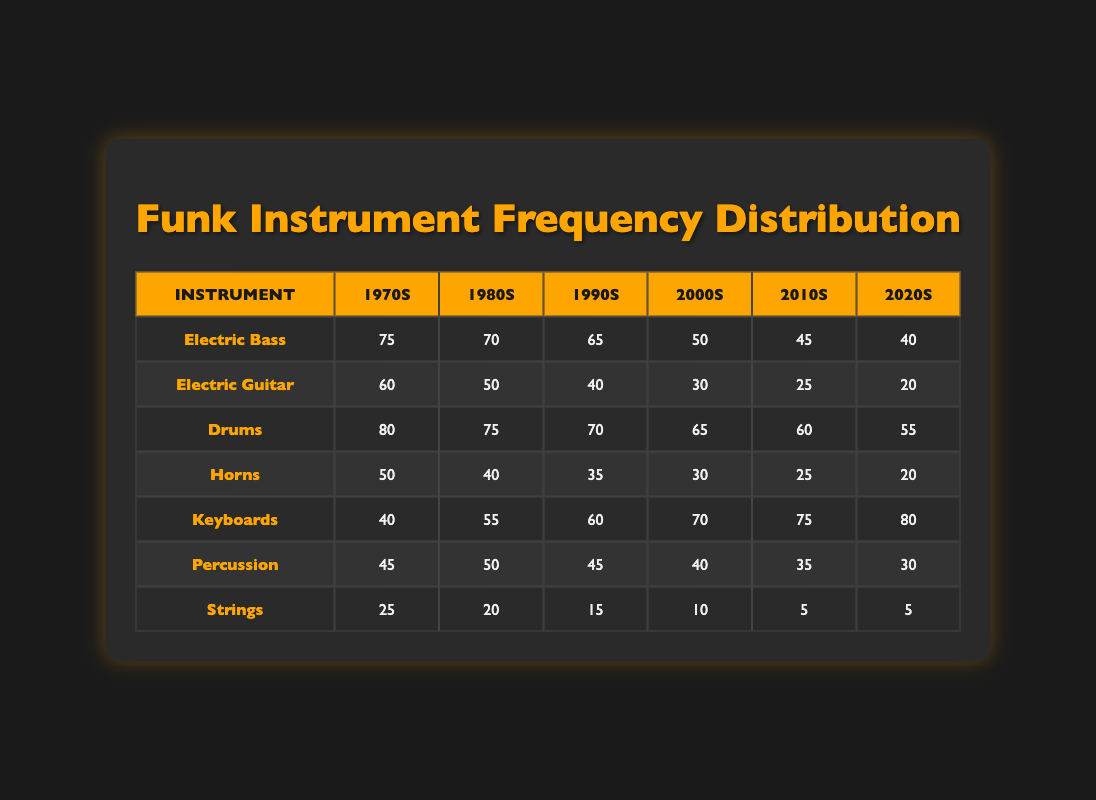What instrument had the highest frequency in the 1970s? From the table, I look at the "1970s" column and find the values for each instrument. The instrument with the highest frequency is "Drums" with a frequency of 80.
Answer: Drums What was the lowest frequency for the "Electric Guitar" over the decades? I check the values for "Electric Guitar" in each decade in the table. The lowest frequency is found in the 2020s with a frequency of 20.
Answer: 20 In which decade did the use of "Horns" see the largest decrease from the previous decade? I compare the "Horns" frequency values between the decades. The values are 50 (1970s), 40 (1980s), 35 (1990s), 30 (2000s), 25 (2010s), and 20 (2020s). The largest decrease occurs when going from the 1970s (50) to the 1980s (40), which is a decrease of 10.
Answer: 1980s What is the average frequency of "Keyboards" across the decades? To find the average frequency, I first sum the frequencies of "Keyboards": 40 + 55 + 60 + 70 + 75 + 80 = 380. Then, I divide this sum by the number of decades (6). So, the average is 380 / 6 = approximately 63.33.
Answer: 63.33 Did the frequency of "Strings" increase at any point during the decades? By examining the frequencies for "Strings" in each decade, I see they are 25 (1970s), 20 (1980s), 15 (1990s), 10 (2000s), 5 (2010s), and 5 (2020s). There is no increase; in fact, the frequency consistently decreases.
Answer: No Which instrument had the strongest showing in the 2010s compared to the previous decade? I look at the 2010s values: Electric Bass (45), Electric Guitar (25), Drums (60), Horns (25), Keyboards (75), Percussion (35), Strings (5) and compare them to the 2000s. Electric Bass decreased, Electric Guitar decreased, Drums decreased, Horns decreased, Keyboards increased from 70 to 75, Percussion decreased, and Strings decreased. The only increase is from Keyboards.
Answer: Keyboards In total, how many frequencies for "Electric Bass" across the decades exceed 60? I check the frequencies for "Electric Bass": 75 (1970s), 70 (1980s), 65 (1990s), 50 (2000s), 45 (2010s), and 40 (2020s). The frequencies greater than 60 are from the 1970s, 1980s, and 1990s, totaling 3 decades where the frequency exceeds 60.
Answer: 3 What is the difference in frequency for "Drums" between the 1970s and the 2020s? I look at the frequency for "Drums" in the 1970s, which is 80, and the frequency for 2020s, which is 55. The difference is 80 - 55 = 25.
Answer: 25 Which decade featured the same frequency for "Strings"? I check the frequencies for "Strings" in each decade: 25, 20, 15, 10, 5, and 5. The 2010s and 2020s both feature a frequency of 5, making these decades the same.
Answer: 2010s and 2020s 